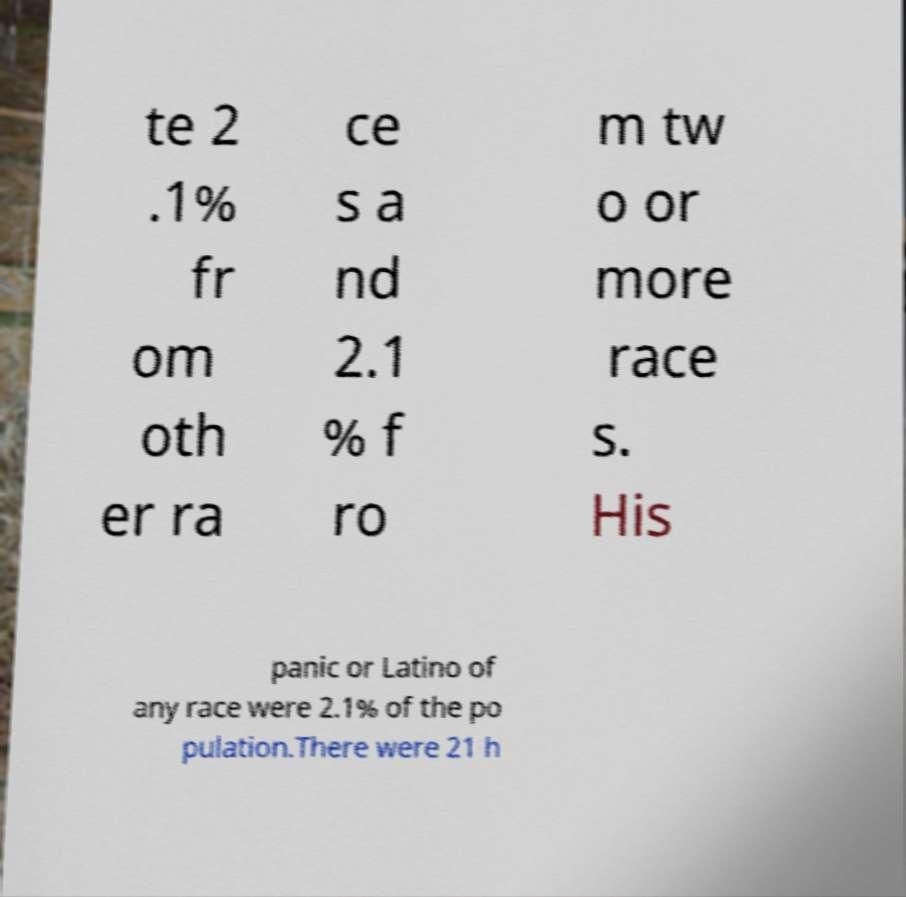Can you read and provide the text displayed in the image?This photo seems to have some interesting text. Can you extract and type it out for me? te 2 .1% fr om oth er ra ce s a nd 2.1 % f ro m tw o or more race s. His panic or Latino of any race were 2.1% of the po pulation.There were 21 h 